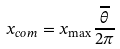Convert formula to latex. <formula><loc_0><loc_0><loc_500><loc_500>x _ { c o m } = x _ { \max } \frac { \overline { \theta } } { 2 \pi }</formula> 